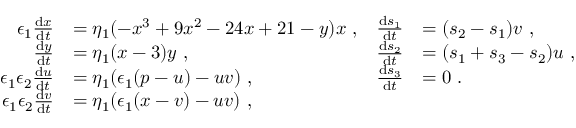Convert formula to latex. <formula><loc_0><loc_0><loc_500><loc_500>\begin{array} { r l r l } { \epsilon _ { 1 } \frac { d x } { d t } } & { = \eta _ { 1 } ( - x ^ { 3 } + 9 x ^ { 2 } - 2 4 x + 2 1 - y ) x \ , } & { \frac { d s _ { 1 } } { d t } } & { = ( s _ { 2 } - s _ { 1 } ) v \ , } \\ { \frac { d y } { d t } } & { = \eta _ { 1 } ( x - 3 ) y \ , } & { \frac { d s _ { 2 } } { d t } } & { = ( s _ { 1 } + s _ { 3 } - s _ { 2 } ) u \ , } \\ { \epsilon _ { 1 } \epsilon _ { 2 } \frac { d u } { d t } } & { = \eta _ { 1 } ( \epsilon _ { 1 } ( p - u ) - u v ) \ , } & { \frac { d s _ { 3 } } { d t } } & { = 0 \ . } \\ { \epsilon _ { 1 } \epsilon _ { 2 } \frac { d v } { d t } } & { = \eta _ { 1 } ( \epsilon _ { 1 } ( x - v ) - u v ) \ , } \end{array}</formula> 